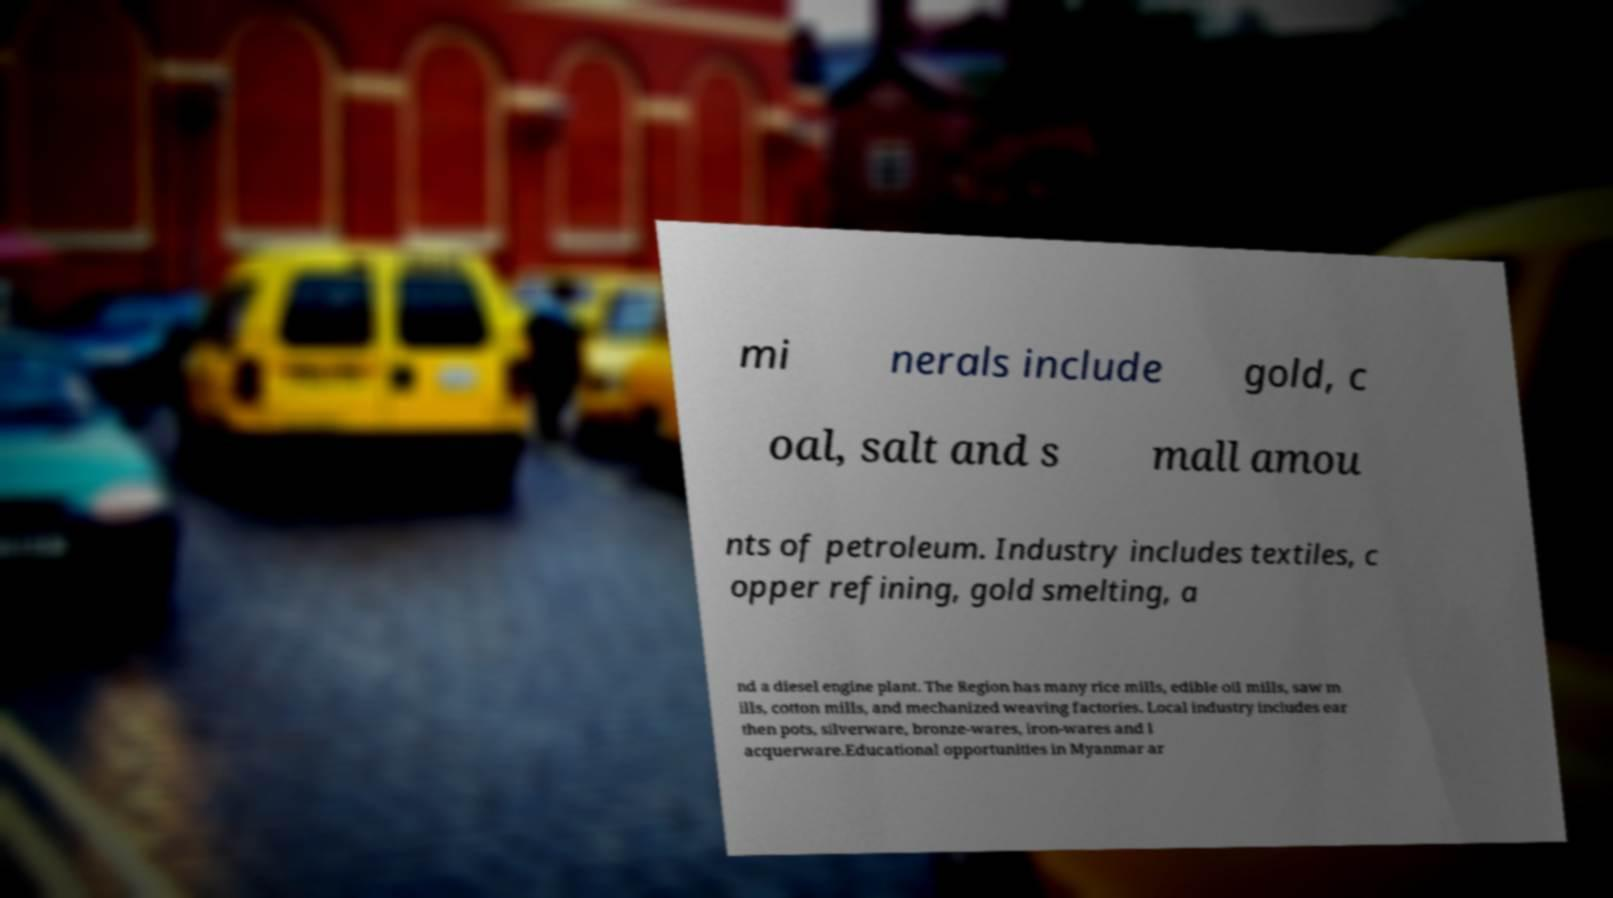Could you extract and type out the text from this image? mi nerals include gold, c oal, salt and s mall amou nts of petroleum. Industry includes textiles, c opper refining, gold smelting, a nd a diesel engine plant. The Region has many rice mills, edible oil mills, saw m ills, cotton mills, and mechanized weaving factories. Local industry includes ear then pots, silverware, bronze-wares, iron-wares and l acquerware.Educational opportunities in Myanmar ar 